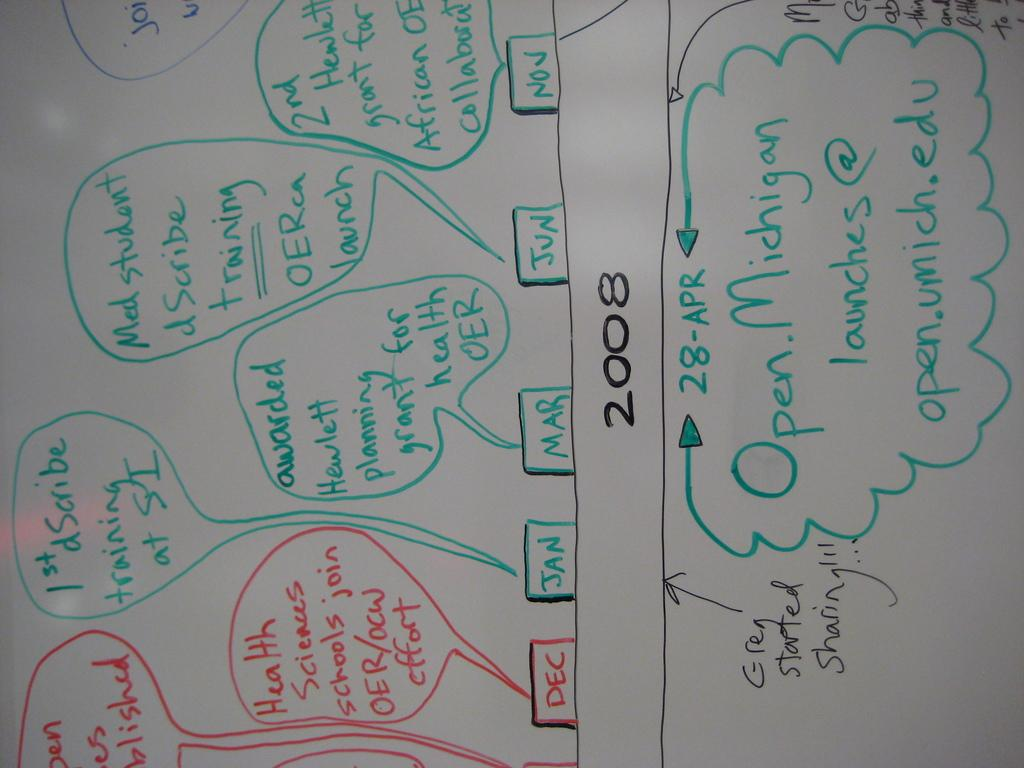<image>
Provide a brief description of the given image. A whiteboard with Health Sciences schools join for december. 